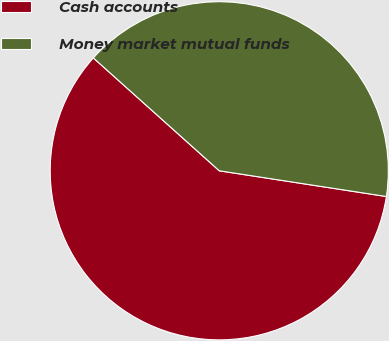Convert chart. <chart><loc_0><loc_0><loc_500><loc_500><pie_chart><fcel>Cash accounts<fcel>Money market mutual funds<nl><fcel>59.2%<fcel>40.8%<nl></chart> 